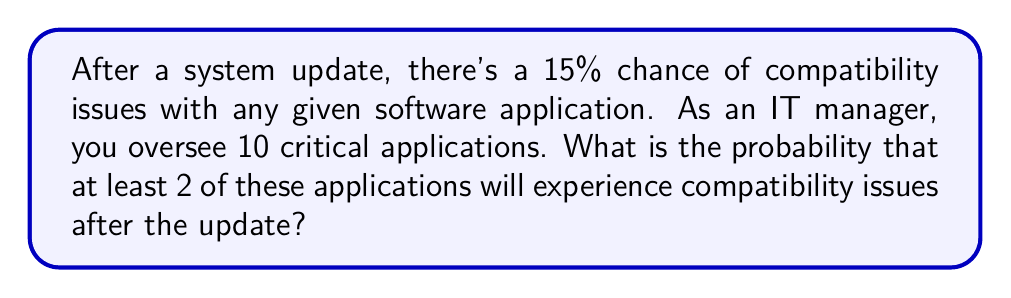Teach me how to tackle this problem. Let's approach this step-by-step:

1) First, we need to recognize this as a binomial probability problem.

2) Let $p$ be the probability of success (an application having compatibility issues), and $q$ be the probability of failure (no issues).

   $p = 0.15$ and $q = 1 - p = 0.85$

3) We want the probability of at least 2 successes out of 10 trials. It's easier to calculate the probability of 0 or 1 success and subtract from 1.

4) The probability of exactly $k$ successes in $n$ trials is given by the binomial probability formula:

   $$P(X = k) = \binom{n}{k} p^k q^{n-k}$$

5) For 0 successes:
   $$P(X = 0) = \binom{10}{0} 0.15^0 0.85^{10} = 0.85^{10} \approx 0.1969$$

6) For 1 success:
   $$P(X = 1) = \binom{10}{1} 0.15^1 0.85^9 = 10 \cdot 0.15 \cdot 0.85^9 \approx 0.3474$$

7) The probability of at least 2 successes is:
   $$P(X \geq 2) = 1 - P(X < 2) = 1 - [P(X = 0) + P(X = 1)]$$
   $$= 1 - (0.1969 + 0.3474) = 1 - 0.5443 = 0.4557$$

Therefore, the probability of at least 2 applications experiencing compatibility issues is approximately 0.4557 or 45.57%.
Answer: 0.4557 